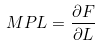<formula> <loc_0><loc_0><loc_500><loc_500>M P L = \frac { \partial F } { \partial L }</formula> 